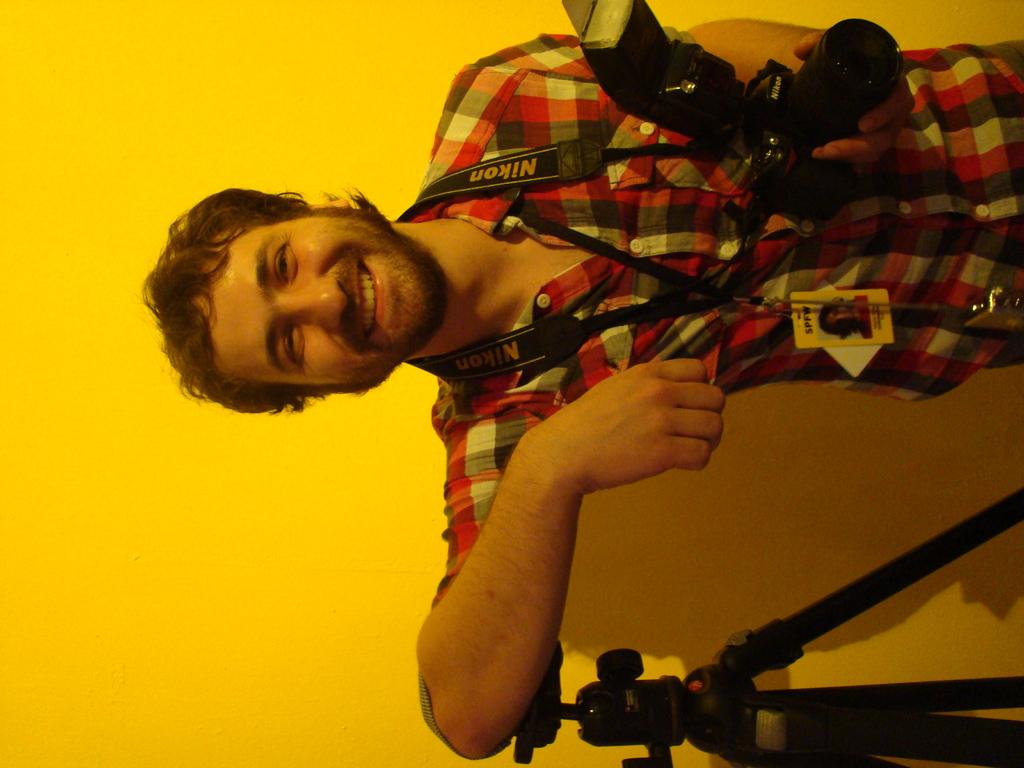What is the main subject of the image? There is a man in the image. What is the man doing in the image? The man is standing in the image. What is the man holding in his hand? The man is holding a camera in his hand. What can be seen in the image that might be used for stabilizing the camera? There is a tripod in the image. What is visible in the background of the image? There is a wall in the background of the image. What type of bed can be seen in the image? There is no bed present in the image. How many cattle are visible in the image? There are no cattle visible in the image. 